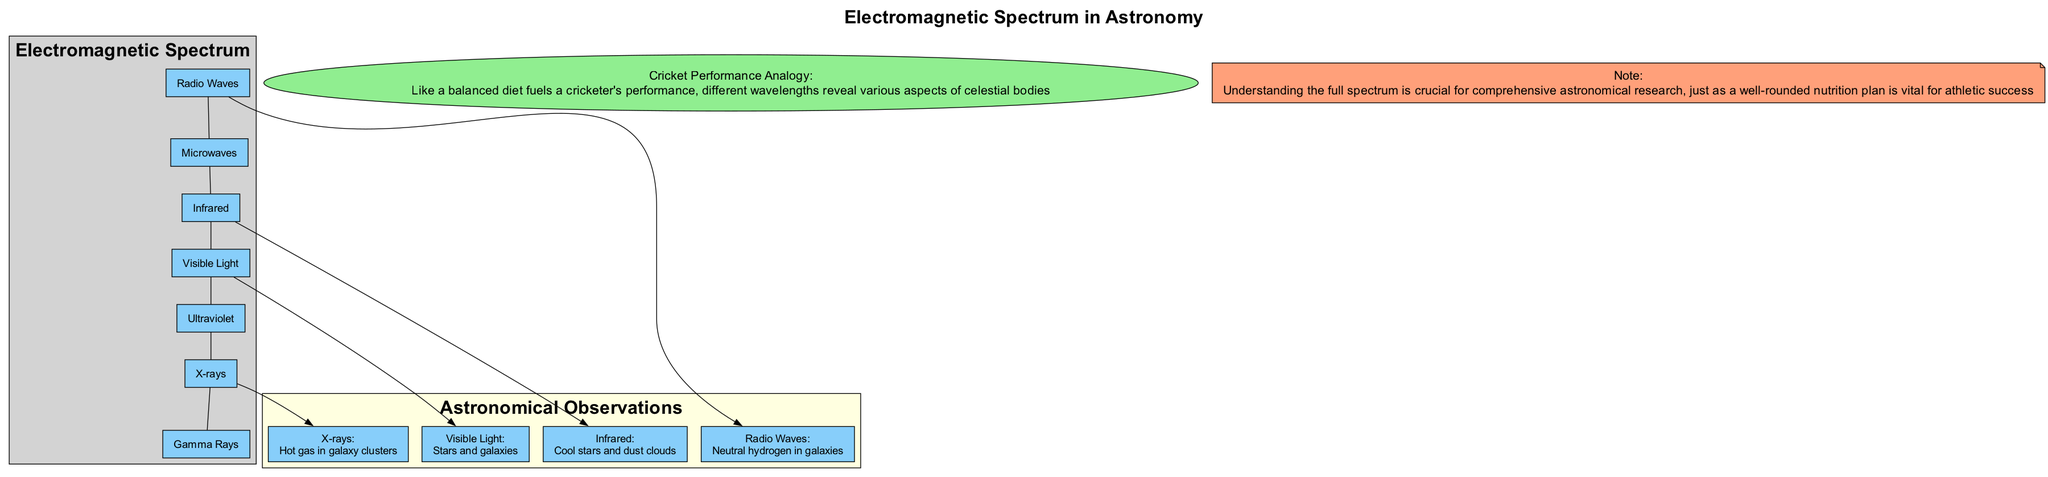What are the seven components of the electromagnetic spectrum? The diagram lists seven components: Radio Waves, Microwaves, Infrared, Visible Light, Ultraviolet, X-rays, and Gamma Rays.
Answer: Radio Waves, Microwaves, Infrared, Visible Light, Ultraviolet, X-rays, Gamma Rays Which wavelength is associated with observing hot gas in galaxy clusters? Looking at the observations for each wavelength, X-rays are linked to the observation of hot gas in galaxy clusters.
Answer: X-rays How many types of astronomical observations are illustrated in the diagram? The diagram shows four types of astronomical observations corresponding to different wavelengths: Radio Waves, Infrared, Visible Light, and X-rays. Thus, the total is four.
Answer: 4 What wavelength is used to observe cool stars and dust clouds? From the observations provided, the wavelength used to observe cool stars and dust clouds is Infrared.
Answer: Infrared Which two wavelengths connect to the observation of stars and galaxies? The observation of stars and galaxies corresponds to Visible Light. The related wavelength from the spectrum is also Visible Light itself, making it the only connection.
Answer: Visible Light How is understanding the full spectrum important in astronomy? The note emphasizes that understanding the full spectrum is crucial for comprehensive astronomical research, similar to how a well-rounded nutrition plan is vital for athletic success.
Answer: Comprehensive understanding What analogy is made between the electromagnetic spectrum and athletic performance? The analogy drawn in the diagram is that like a balanced diet fuels a cricketer’s performance, different wavelengths of the electromagnetic spectrum reveal various aspects of celestial bodies.
Answer: Balanced diet analogy 